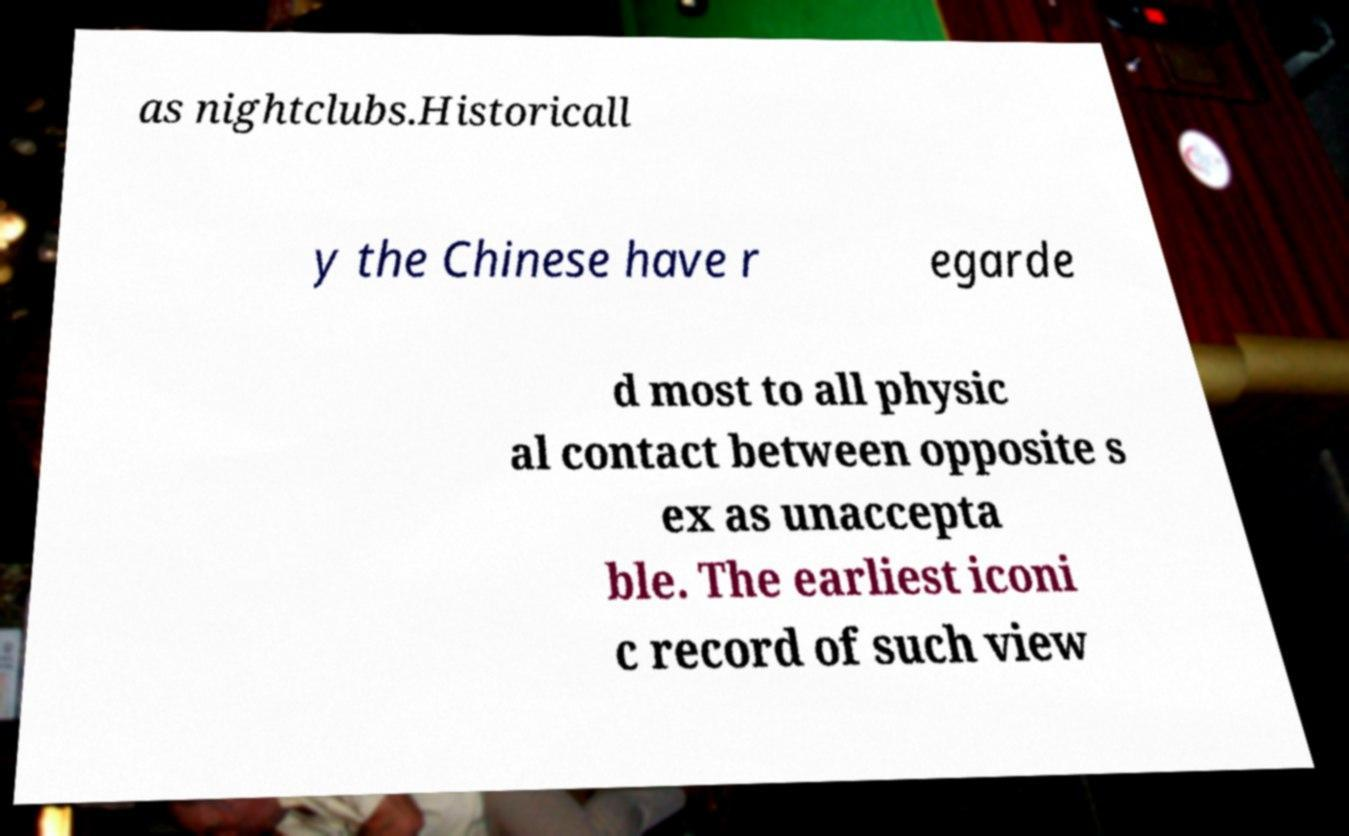For documentation purposes, I need the text within this image transcribed. Could you provide that? as nightclubs.Historicall y the Chinese have r egarde d most to all physic al contact between opposite s ex as unaccepta ble. The earliest iconi c record of such view 